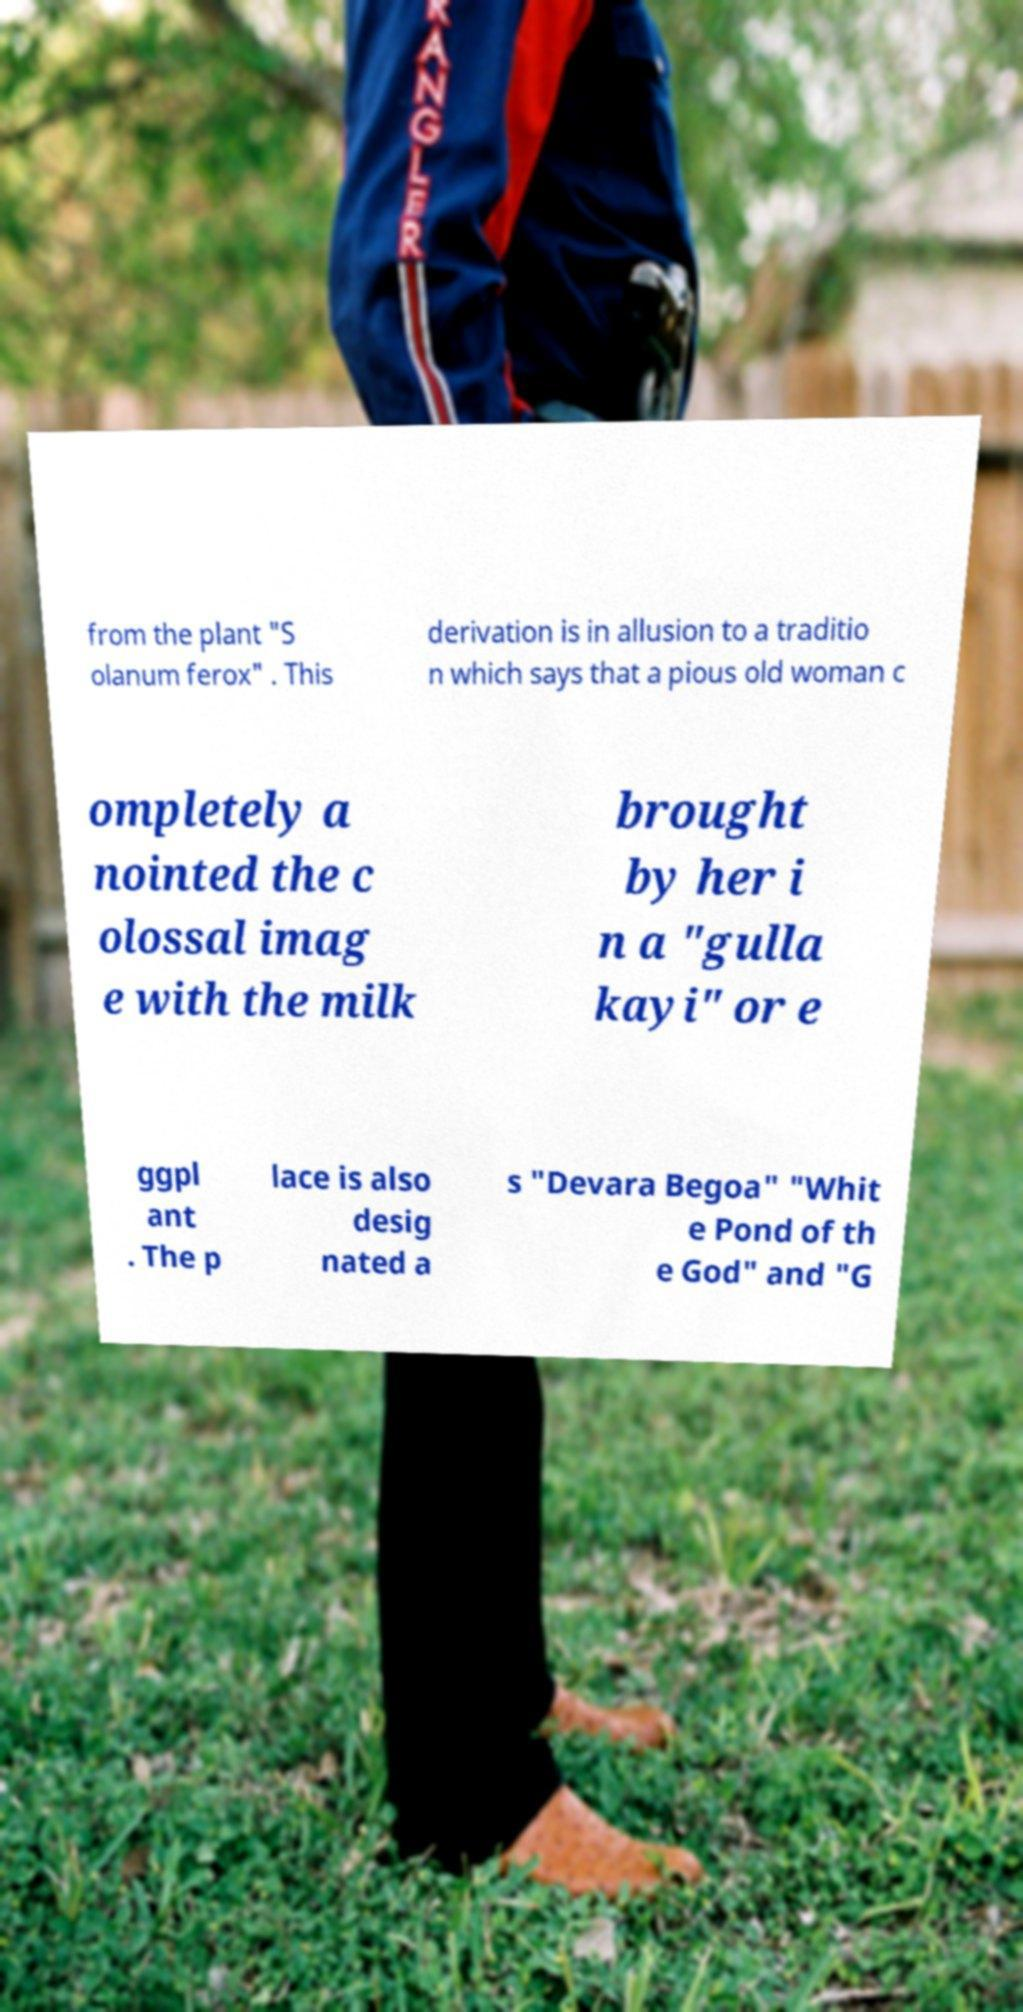Can you read and provide the text displayed in the image?This photo seems to have some interesting text. Can you extract and type it out for me? from the plant "S olanum ferox" . This derivation is in allusion to a traditio n which says that a pious old woman c ompletely a nointed the c olossal imag e with the milk brought by her i n a "gulla kayi" or e ggpl ant . The p lace is also desig nated a s "Devara Begoa" "Whit e Pond of th e God" and "G 